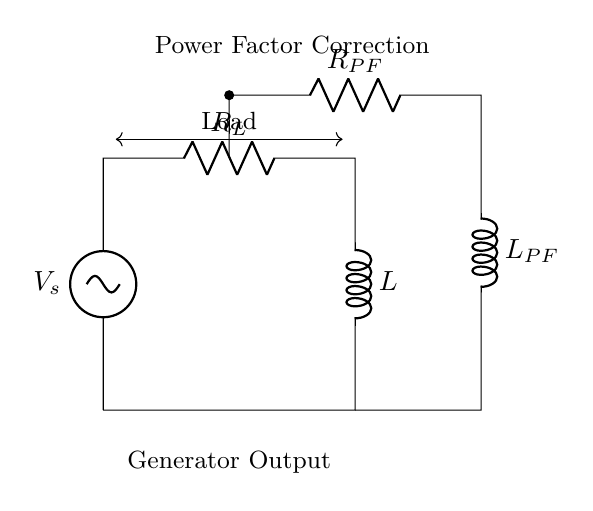What is the main source of voltage in this circuit? The voltage source indicated in the diagram is labeled as V_s, which serves as the primary voltage supply to the circuit.
Answer: V_s What components are used for power factor correction? The circuit shows two components labeled R_PF and L_PF, which are specifically included to improve the power factor in the system.
Answer: R_PF and L_PF What type of components are used in the circuit? The circuit includes resistors and inductors; R_L is a resistor, and L is an inductor. Additionally, R_PF and L_PF are also resistors and inductors used for power factor correction.
Answer: Resistors and inductors How many inductors are present in the circuit? There are two inductors in the circuit; one labeled as L and the other labeled as L_PF for power factor correction.
Answer: 2 What is the function of the load indicated in the diagram? The load represents the device or system that consumes electrical power, showing where the generator's output is delivered.
Answer: To consume power Why is power factor correction necessary in this circuit? Power factor correction is important to improve the efficiency of power delivery and reduce losses in the system, which is particularly important for generators that may experience reactive power issues.
Answer: To improve efficiency and reduce losses 